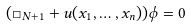<formula> <loc_0><loc_0><loc_500><loc_500>( \Box _ { N + 1 } + u ( x _ { 1 } , \dots , x _ { n } ) ) \phi = 0</formula> 